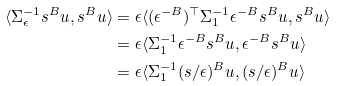Convert formula to latex. <formula><loc_0><loc_0><loc_500><loc_500>\langle { \Sigma } _ { \epsilon } ^ { - 1 } s ^ { B } u , s ^ { B } u \rangle & = \epsilon \langle ( \epsilon ^ { - B } ) ^ { \top } \Sigma _ { 1 } ^ { - 1 } \epsilon ^ { - B } s ^ { B } u , s ^ { B } u \rangle \\ & = \epsilon \langle \Sigma _ { 1 } ^ { - 1 } \epsilon ^ { - B } s ^ { B } u , \epsilon ^ { - B } s ^ { B } u \rangle \\ & = \epsilon \langle \Sigma _ { 1 } ^ { - 1 } ( s / \epsilon ) ^ { B } u , ( s / \epsilon ) ^ { B } u \rangle</formula> 